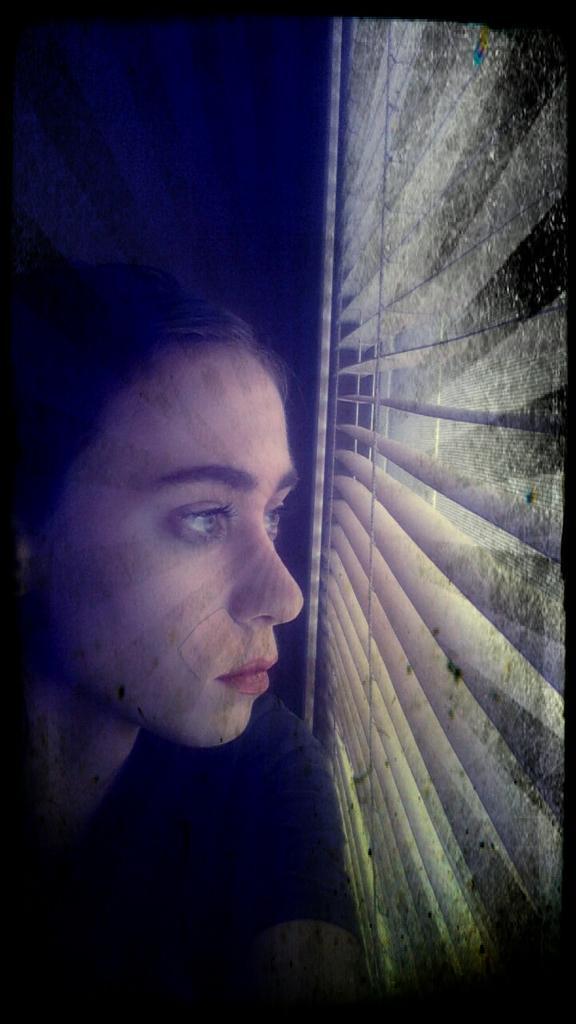Please provide a concise description of this image. This is an edited image , where there is a person near the window shutter. 